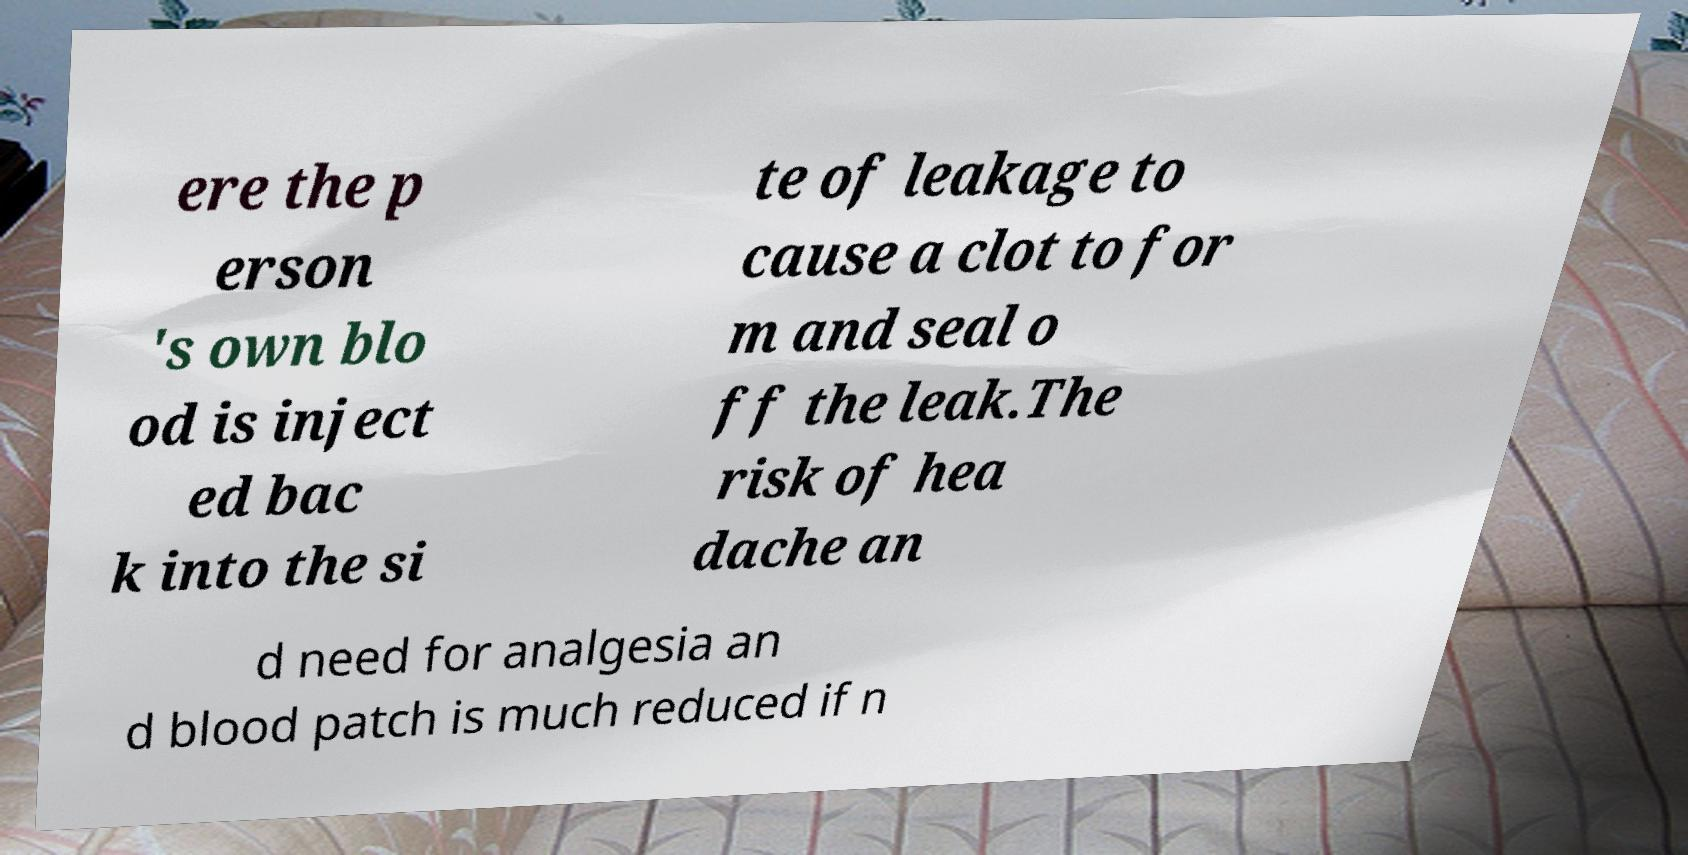I need the written content from this picture converted into text. Can you do that? ere the p erson 's own blo od is inject ed bac k into the si te of leakage to cause a clot to for m and seal o ff the leak.The risk of hea dache an d need for analgesia an d blood patch is much reduced if n 